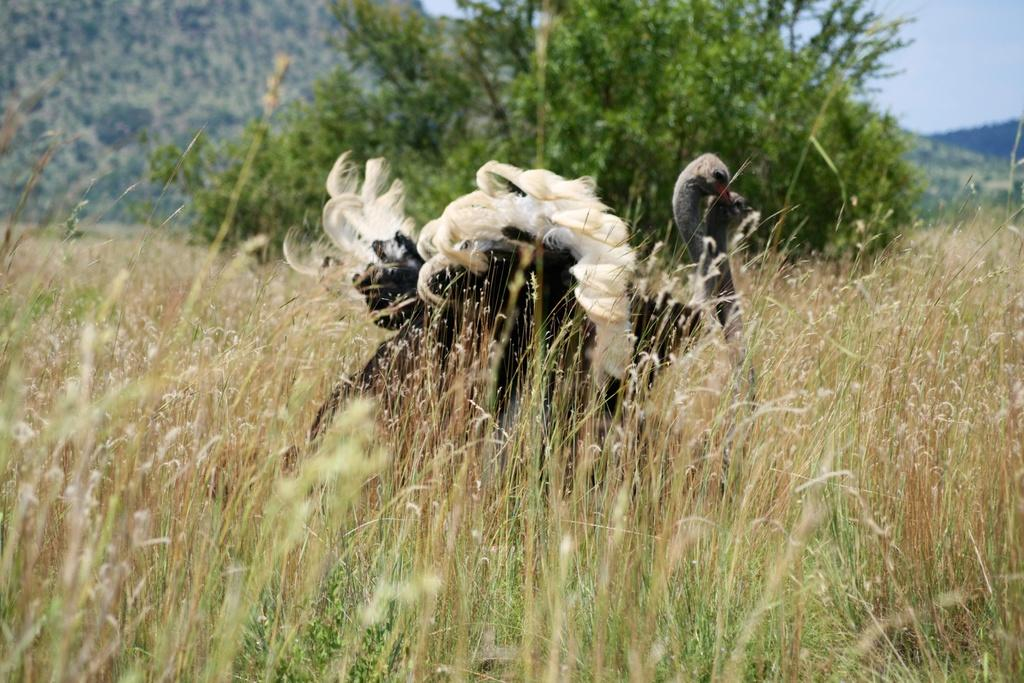What type of birds are in the image? There are two black ibis in the image. Where are the ibis located? The ibis are standing on the grass. What can be seen in the background of the image? There are trees on the bank and mountains visible in the image. What is the condition of the sky in the image? The sky is visible in the top right corner of the image. What type of landscape is present in the image? There is a farmland in the image. What type of door can be seen on the ibis in the image? There are no doors present on the ibis in the image; they are birds. Do the ibis have fangs in the image? Birds, including ibis, do not have fangs, so there are no fangs present in the image. 